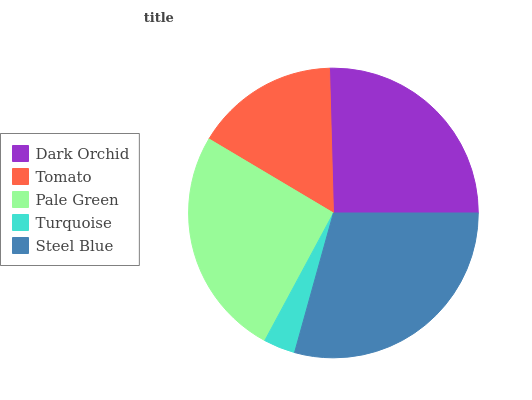Is Turquoise the minimum?
Answer yes or no. Yes. Is Steel Blue the maximum?
Answer yes or no. Yes. Is Tomato the minimum?
Answer yes or no. No. Is Tomato the maximum?
Answer yes or no. No. Is Dark Orchid greater than Tomato?
Answer yes or no. Yes. Is Tomato less than Dark Orchid?
Answer yes or no. Yes. Is Tomato greater than Dark Orchid?
Answer yes or no. No. Is Dark Orchid less than Tomato?
Answer yes or no. No. Is Dark Orchid the high median?
Answer yes or no. Yes. Is Dark Orchid the low median?
Answer yes or no. Yes. Is Steel Blue the high median?
Answer yes or no. No. Is Pale Green the low median?
Answer yes or no. No. 